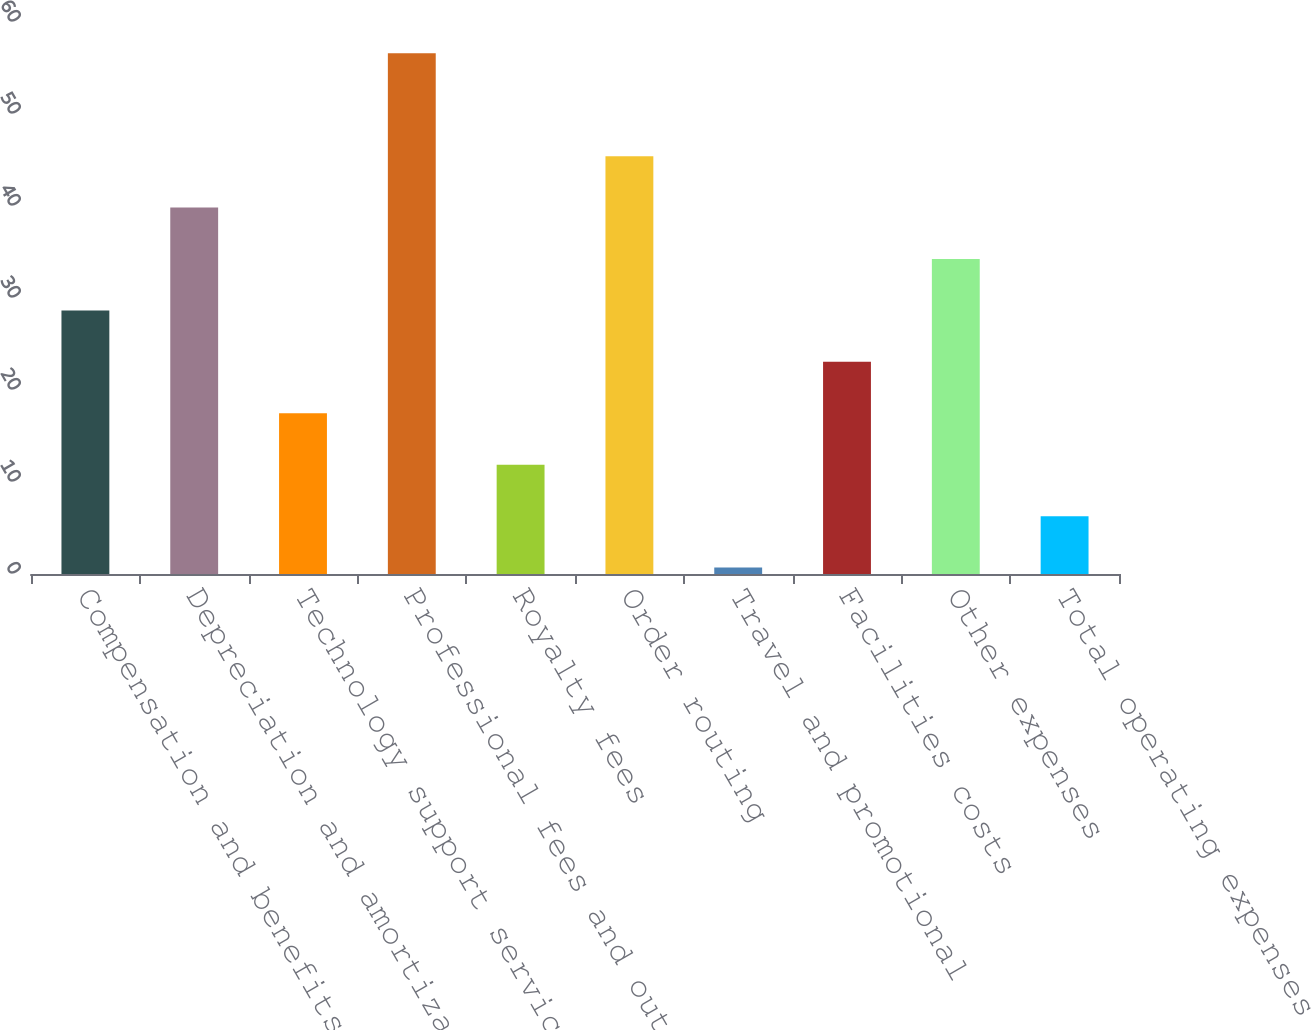Convert chart to OTSL. <chart><loc_0><loc_0><loc_500><loc_500><bar_chart><fcel>Compensation and benefits<fcel>Depreciation and amortization<fcel>Technology support services<fcel>Professional fees and outside<fcel>Royalty fees<fcel>Order routing<fcel>Travel and promotional<fcel>Facilities costs<fcel>Other expenses<fcel>Total operating expenses<nl><fcel>28.65<fcel>39.83<fcel>17.47<fcel>56.6<fcel>11.88<fcel>45.42<fcel>0.7<fcel>23.06<fcel>34.24<fcel>6.29<nl></chart> 